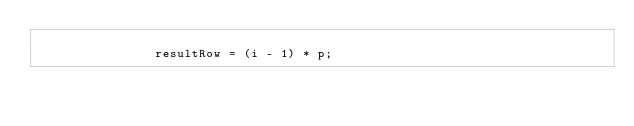<code> <loc_0><loc_0><loc_500><loc_500><_C_>
                resultRow = (i - 1) * p;</code> 